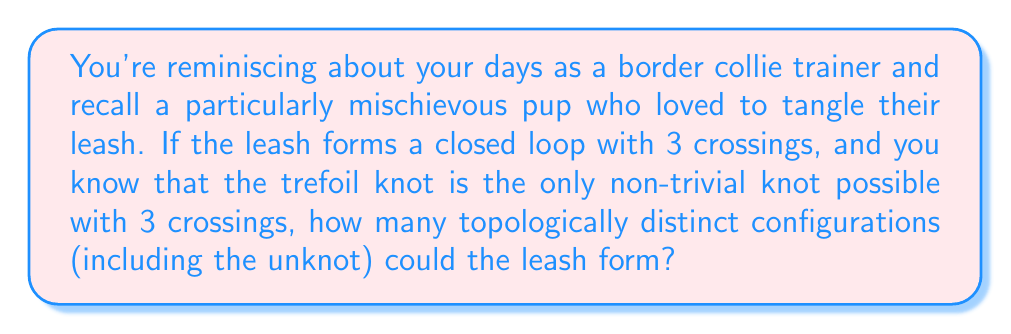What is the answer to this math problem? Let's approach this step-by-step:

1) In knot theory, we consider knots that can be deformed into each other without cutting the rope as equivalent. These are called topologically equivalent knots.

2) With 3 crossings, we have two possibilities:

   a) The unknot (trivial knot): This is a simple loop with no actual knots. Despite having 3 crossings, it can be unraveled to a simple circle.

   b) The trefoil knot: This is the simplest non-trivial knot, and it's the only non-trivial knot possible with 3 crossings.

3) The trefoil knot can appear in two forms:
   
   a) Right-handed trefoil
   b) Left-handed trefoil

4) However, these two forms are actually mirror images of each other. In knot theory, we consider mirror images as the same knot unless explicitly stated otherwise.

5) Therefore, we have only two topologically distinct configurations:
   
   a) The unknot
   b) The trefoil knot

Thus, there are 2 topologically distinct configurations possible for the leash.
Answer: 2 